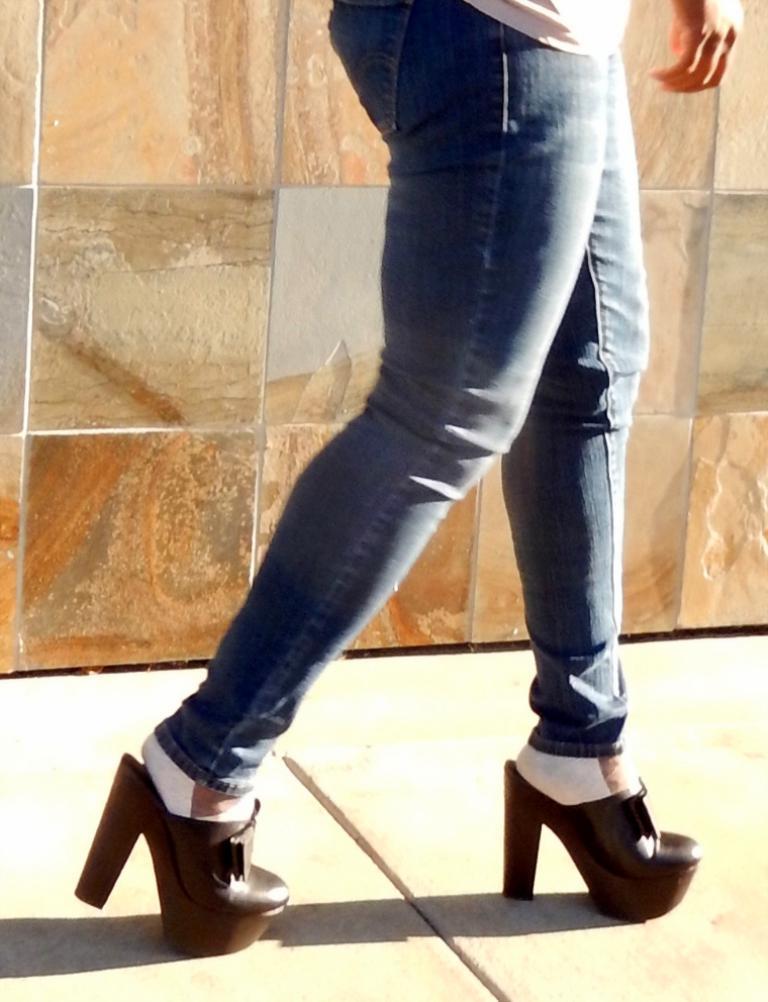How would you summarize this image in a sentence or two? In this image we can see a person truncated and walking on the floor, in the background we can see the wall. 